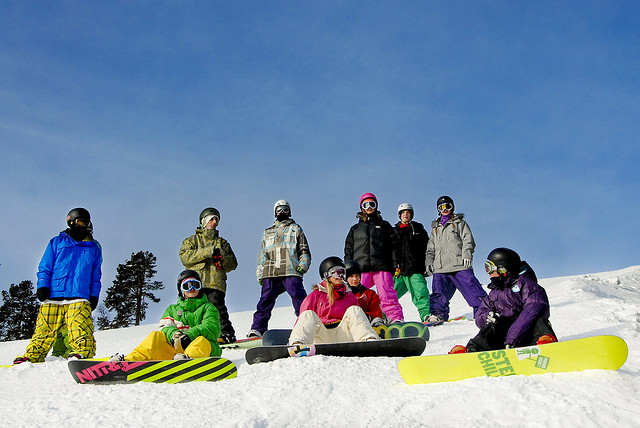Identify and read out the text in this image. STE CHIL 